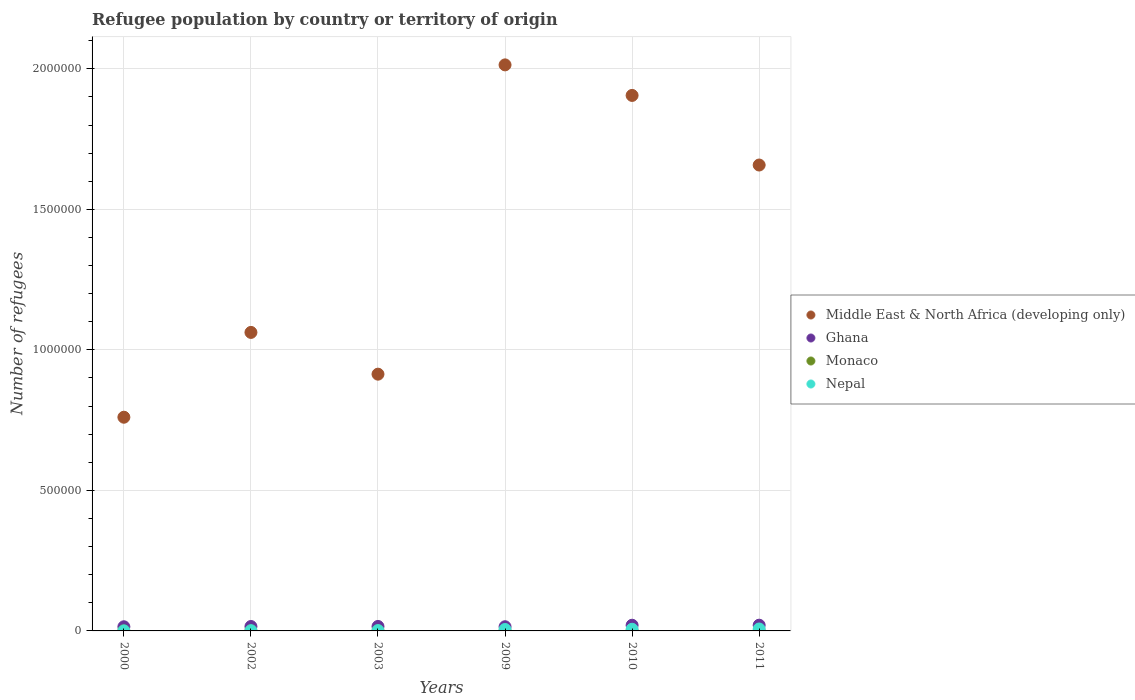How many different coloured dotlines are there?
Offer a very short reply. 4. What is the number of refugees in Nepal in 2003?
Your response must be concise. 1231. Across all years, what is the maximum number of refugees in Middle East & North Africa (developing only)?
Provide a succinct answer. 2.01e+06. Across all years, what is the minimum number of refugees in Nepal?
Your answer should be very brief. 235. What is the total number of refugees in Monaco in the graph?
Make the answer very short. 10. What is the difference between the number of refugees in Ghana in 2000 and that in 2002?
Your answer should be very brief. -911. What is the difference between the number of refugees in Ghana in 2011 and the number of refugees in Middle East & North Africa (developing only) in 2010?
Your answer should be compact. -1.88e+06. What is the average number of refugees in Monaco per year?
Your answer should be very brief. 1.67. In the year 2009, what is the difference between the number of refugees in Nepal and number of refugees in Monaco?
Offer a very short reply. 5107. In how many years, is the number of refugees in Middle East & North Africa (developing only) greater than 1700000?
Provide a short and direct response. 2. What is the ratio of the number of refugees in Middle East & North Africa (developing only) in 2002 to that in 2010?
Keep it short and to the point. 0.56. Is the number of refugees in Ghana in 2000 less than that in 2009?
Your answer should be compact. Yes. Is the difference between the number of refugees in Nepal in 2003 and 2011 greater than the difference between the number of refugees in Monaco in 2003 and 2011?
Make the answer very short. No. What is the difference between the highest and the second highest number of refugees in Middle East & North Africa (developing only)?
Offer a very short reply. 1.09e+05. What is the difference between the highest and the lowest number of refugees in Monaco?
Give a very brief answer. 3. Is the sum of the number of refugees in Nepal in 2002 and 2003 greater than the maximum number of refugees in Monaco across all years?
Make the answer very short. Yes. Is it the case that in every year, the sum of the number of refugees in Monaco and number of refugees in Middle East & North Africa (developing only)  is greater than the sum of number of refugees in Ghana and number of refugees in Nepal?
Give a very brief answer. Yes. How many years are there in the graph?
Provide a succinct answer. 6. Does the graph contain grids?
Give a very brief answer. Yes. What is the title of the graph?
Your answer should be compact. Refugee population by country or territory of origin. Does "Low income" appear as one of the legend labels in the graph?
Offer a very short reply. No. What is the label or title of the X-axis?
Offer a very short reply. Years. What is the label or title of the Y-axis?
Provide a short and direct response. Number of refugees. What is the Number of refugees in Middle East & North Africa (developing only) in 2000?
Provide a short and direct response. 7.60e+05. What is the Number of refugees of Ghana in 2000?
Offer a very short reply. 1.48e+04. What is the Number of refugees in Monaco in 2000?
Provide a short and direct response. 1. What is the Number of refugees of Nepal in 2000?
Your response must be concise. 235. What is the Number of refugees in Middle East & North Africa (developing only) in 2002?
Provide a succinct answer. 1.06e+06. What is the Number of refugees in Ghana in 2002?
Offer a terse response. 1.57e+04. What is the Number of refugees in Nepal in 2002?
Your answer should be very brief. 902. What is the Number of refugees of Middle East & North Africa (developing only) in 2003?
Offer a terse response. 9.14e+05. What is the Number of refugees in Ghana in 2003?
Ensure brevity in your answer.  1.59e+04. What is the Number of refugees of Nepal in 2003?
Offer a very short reply. 1231. What is the Number of refugees in Middle East & North Africa (developing only) in 2009?
Offer a terse response. 2.01e+06. What is the Number of refugees of Ghana in 2009?
Keep it short and to the point. 1.49e+04. What is the Number of refugees in Monaco in 2009?
Offer a very short reply. 1. What is the Number of refugees in Nepal in 2009?
Offer a terse response. 5108. What is the Number of refugees of Middle East & North Africa (developing only) in 2010?
Your response must be concise. 1.91e+06. What is the Number of refugees of Ghana in 2010?
Your answer should be compact. 2.02e+04. What is the Number of refugees of Monaco in 2010?
Your answer should be compact. 2. What is the Number of refugees in Nepal in 2010?
Offer a very short reply. 5889. What is the Number of refugees of Middle East & North Africa (developing only) in 2011?
Offer a very short reply. 1.66e+06. What is the Number of refugees of Ghana in 2011?
Your answer should be compact. 2.04e+04. What is the Number of refugees in Monaco in 2011?
Offer a terse response. 4. What is the Number of refugees of Nepal in 2011?
Offer a very short reply. 6854. Across all years, what is the maximum Number of refugees in Middle East & North Africa (developing only)?
Keep it short and to the point. 2.01e+06. Across all years, what is the maximum Number of refugees of Ghana?
Offer a terse response. 2.04e+04. Across all years, what is the maximum Number of refugees in Monaco?
Ensure brevity in your answer.  4. Across all years, what is the maximum Number of refugees of Nepal?
Provide a short and direct response. 6854. Across all years, what is the minimum Number of refugees of Middle East & North Africa (developing only)?
Your answer should be compact. 7.60e+05. Across all years, what is the minimum Number of refugees of Ghana?
Keep it short and to the point. 1.48e+04. Across all years, what is the minimum Number of refugees of Monaco?
Your answer should be compact. 1. Across all years, what is the minimum Number of refugees of Nepal?
Ensure brevity in your answer.  235. What is the total Number of refugees of Middle East & North Africa (developing only) in the graph?
Your answer should be compact. 8.31e+06. What is the total Number of refugees in Ghana in the graph?
Provide a short and direct response. 1.02e+05. What is the total Number of refugees of Monaco in the graph?
Provide a short and direct response. 10. What is the total Number of refugees in Nepal in the graph?
Your answer should be compact. 2.02e+04. What is the difference between the Number of refugees of Middle East & North Africa (developing only) in 2000 and that in 2002?
Offer a terse response. -3.02e+05. What is the difference between the Number of refugees in Ghana in 2000 and that in 2002?
Your response must be concise. -911. What is the difference between the Number of refugees of Nepal in 2000 and that in 2002?
Your answer should be very brief. -667. What is the difference between the Number of refugees in Middle East & North Africa (developing only) in 2000 and that in 2003?
Provide a short and direct response. -1.53e+05. What is the difference between the Number of refugees of Ghana in 2000 and that in 2003?
Make the answer very short. -1104. What is the difference between the Number of refugees in Nepal in 2000 and that in 2003?
Keep it short and to the point. -996. What is the difference between the Number of refugees in Middle East & North Africa (developing only) in 2000 and that in 2009?
Keep it short and to the point. -1.25e+06. What is the difference between the Number of refugees in Ghana in 2000 and that in 2009?
Offer a very short reply. -118. What is the difference between the Number of refugees of Nepal in 2000 and that in 2009?
Your response must be concise. -4873. What is the difference between the Number of refugees in Middle East & North Africa (developing only) in 2000 and that in 2010?
Your response must be concise. -1.14e+06. What is the difference between the Number of refugees of Ghana in 2000 and that in 2010?
Your response must be concise. -5428. What is the difference between the Number of refugees in Nepal in 2000 and that in 2010?
Make the answer very short. -5654. What is the difference between the Number of refugees of Middle East & North Africa (developing only) in 2000 and that in 2011?
Provide a succinct answer. -8.97e+05. What is the difference between the Number of refugees in Ghana in 2000 and that in 2011?
Keep it short and to the point. -5586. What is the difference between the Number of refugees in Nepal in 2000 and that in 2011?
Your response must be concise. -6619. What is the difference between the Number of refugees of Middle East & North Africa (developing only) in 2002 and that in 2003?
Your response must be concise. 1.49e+05. What is the difference between the Number of refugees in Ghana in 2002 and that in 2003?
Offer a terse response. -193. What is the difference between the Number of refugees in Nepal in 2002 and that in 2003?
Keep it short and to the point. -329. What is the difference between the Number of refugees of Middle East & North Africa (developing only) in 2002 and that in 2009?
Your answer should be compact. -9.52e+05. What is the difference between the Number of refugees in Ghana in 2002 and that in 2009?
Make the answer very short. 793. What is the difference between the Number of refugees in Nepal in 2002 and that in 2009?
Your response must be concise. -4206. What is the difference between the Number of refugees of Middle East & North Africa (developing only) in 2002 and that in 2010?
Provide a short and direct response. -8.43e+05. What is the difference between the Number of refugees in Ghana in 2002 and that in 2010?
Offer a very short reply. -4517. What is the difference between the Number of refugees of Nepal in 2002 and that in 2010?
Provide a succinct answer. -4987. What is the difference between the Number of refugees in Middle East & North Africa (developing only) in 2002 and that in 2011?
Ensure brevity in your answer.  -5.96e+05. What is the difference between the Number of refugees of Ghana in 2002 and that in 2011?
Provide a succinct answer. -4675. What is the difference between the Number of refugees of Nepal in 2002 and that in 2011?
Your answer should be very brief. -5952. What is the difference between the Number of refugees in Middle East & North Africa (developing only) in 2003 and that in 2009?
Keep it short and to the point. -1.10e+06. What is the difference between the Number of refugees in Ghana in 2003 and that in 2009?
Offer a very short reply. 986. What is the difference between the Number of refugees in Nepal in 2003 and that in 2009?
Your answer should be compact. -3877. What is the difference between the Number of refugees of Middle East & North Africa (developing only) in 2003 and that in 2010?
Offer a terse response. -9.92e+05. What is the difference between the Number of refugees in Ghana in 2003 and that in 2010?
Make the answer very short. -4324. What is the difference between the Number of refugees in Nepal in 2003 and that in 2010?
Provide a short and direct response. -4658. What is the difference between the Number of refugees in Middle East & North Africa (developing only) in 2003 and that in 2011?
Your answer should be very brief. -7.44e+05. What is the difference between the Number of refugees of Ghana in 2003 and that in 2011?
Offer a very short reply. -4482. What is the difference between the Number of refugees in Monaco in 2003 and that in 2011?
Make the answer very short. -3. What is the difference between the Number of refugees of Nepal in 2003 and that in 2011?
Your response must be concise. -5623. What is the difference between the Number of refugees of Middle East & North Africa (developing only) in 2009 and that in 2010?
Keep it short and to the point. 1.09e+05. What is the difference between the Number of refugees of Ghana in 2009 and that in 2010?
Your response must be concise. -5310. What is the difference between the Number of refugees of Monaco in 2009 and that in 2010?
Your answer should be compact. -1. What is the difference between the Number of refugees in Nepal in 2009 and that in 2010?
Offer a terse response. -781. What is the difference between the Number of refugees of Middle East & North Africa (developing only) in 2009 and that in 2011?
Your answer should be compact. 3.56e+05. What is the difference between the Number of refugees in Ghana in 2009 and that in 2011?
Offer a terse response. -5468. What is the difference between the Number of refugees in Nepal in 2009 and that in 2011?
Offer a terse response. -1746. What is the difference between the Number of refugees of Middle East & North Africa (developing only) in 2010 and that in 2011?
Give a very brief answer. 2.48e+05. What is the difference between the Number of refugees in Ghana in 2010 and that in 2011?
Ensure brevity in your answer.  -158. What is the difference between the Number of refugees in Nepal in 2010 and that in 2011?
Make the answer very short. -965. What is the difference between the Number of refugees of Middle East & North Africa (developing only) in 2000 and the Number of refugees of Ghana in 2002?
Offer a terse response. 7.45e+05. What is the difference between the Number of refugees in Middle East & North Africa (developing only) in 2000 and the Number of refugees in Monaco in 2002?
Offer a terse response. 7.60e+05. What is the difference between the Number of refugees in Middle East & North Africa (developing only) in 2000 and the Number of refugees in Nepal in 2002?
Keep it short and to the point. 7.59e+05. What is the difference between the Number of refugees in Ghana in 2000 and the Number of refugees in Monaco in 2002?
Give a very brief answer. 1.48e+04. What is the difference between the Number of refugees in Ghana in 2000 and the Number of refugees in Nepal in 2002?
Provide a short and direct response. 1.39e+04. What is the difference between the Number of refugees of Monaco in 2000 and the Number of refugees of Nepal in 2002?
Your answer should be very brief. -901. What is the difference between the Number of refugees in Middle East & North Africa (developing only) in 2000 and the Number of refugees in Ghana in 2003?
Make the answer very short. 7.44e+05. What is the difference between the Number of refugees in Middle East & North Africa (developing only) in 2000 and the Number of refugees in Monaco in 2003?
Your response must be concise. 7.60e+05. What is the difference between the Number of refugees in Middle East & North Africa (developing only) in 2000 and the Number of refugees in Nepal in 2003?
Ensure brevity in your answer.  7.59e+05. What is the difference between the Number of refugees of Ghana in 2000 and the Number of refugees of Monaco in 2003?
Ensure brevity in your answer.  1.48e+04. What is the difference between the Number of refugees in Ghana in 2000 and the Number of refugees in Nepal in 2003?
Provide a short and direct response. 1.35e+04. What is the difference between the Number of refugees of Monaco in 2000 and the Number of refugees of Nepal in 2003?
Your response must be concise. -1230. What is the difference between the Number of refugees in Middle East & North Africa (developing only) in 2000 and the Number of refugees in Ghana in 2009?
Ensure brevity in your answer.  7.45e+05. What is the difference between the Number of refugees of Middle East & North Africa (developing only) in 2000 and the Number of refugees of Monaco in 2009?
Provide a short and direct response. 7.60e+05. What is the difference between the Number of refugees of Middle East & North Africa (developing only) in 2000 and the Number of refugees of Nepal in 2009?
Keep it short and to the point. 7.55e+05. What is the difference between the Number of refugees in Ghana in 2000 and the Number of refugees in Monaco in 2009?
Your answer should be compact. 1.48e+04. What is the difference between the Number of refugees in Ghana in 2000 and the Number of refugees in Nepal in 2009?
Your response must be concise. 9667. What is the difference between the Number of refugees of Monaco in 2000 and the Number of refugees of Nepal in 2009?
Provide a succinct answer. -5107. What is the difference between the Number of refugees of Middle East & North Africa (developing only) in 2000 and the Number of refugees of Ghana in 2010?
Ensure brevity in your answer.  7.40e+05. What is the difference between the Number of refugees in Middle East & North Africa (developing only) in 2000 and the Number of refugees in Monaco in 2010?
Offer a very short reply. 7.60e+05. What is the difference between the Number of refugees in Middle East & North Africa (developing only) in 2000 and the Number of refugees in Nepal in 2010?
Keep it short and to the point. 7.54e+05. What is the difference between the Number of refugees in Ghana in 2000 and the Number of refugees in Monaco in 2010?
Keep it short and to the point. 1.48e+04. What is the difference between the Number of refugees of Ghana in 2000 and the Number of refugees of Nepal in 2010?
Provide a succinct answer. 8886. What is the difference between the Number of refugees in Monaco in 2000 and the Number of refugees in Nepal in 2010?
Your answer should be compact. -5888. What is the difference between the Number of refugees in Middle East & North Africa (developing only) in 2000 and the Number of refugees in Ghana in 2011?
Ensure brevity in your answer.  7.40e+05. What is the difference between the Number of refugees of Middle East & North Africa (developing only) in 2000 and the Number of refugees of Monaco in 2011?
Make the answer very short. 7.60e+05. What is the difference between the Number of refugees in Middle East & North Africa (developing only) in 2000 and the Number of refugees in Nepal in 2011?
Your answer should be compact. 7.53e+05. What is the difference between the Number of refugees of Ghana in 2000 and the Number of refugees of Monaco in 2011?
Your answer should be compact. 1.48e+04. What is the difference between the Number of refugees in Ghana in 2000 and the Number of refugees in Nepal in 2011?
Provide a short and direct response. 7921. What is the difference between the Number of refugees in Monaco in 2000 and the Number of refugees in Nepal in 2011?
Your answer should be very brief. -6853. What is the difference between the Number of refugees in Middle East & North Africa (developing only) in 2002 and the Number of refugees in Ghana in 2003?
Ensure brevity in your answer.  1.05e+06. What is the difference between the Number of refugees in Middle East & North Africa (developing only) in 2002 and the Number of refugees in Monaco in 2003?
Provide a short and direct response. 1.06e+06. What is the difference between the Number of refugees in Middle East & North Africa (developing only) in 2002 and the Number of refugees in Nepal in 2003?
Make the answer very short. 1.06e+06. What is the difference between the Number of refugees in Ghana in 2002 and the Number of refugees in Monaco in 2003?
Keep it short and to the point. 1.57e+04. What is the difference between the Number of refugees of Ghana in 2002 and the Number of refugees of Nepal in 2003?
Provide a short and direct response. 1.45e+04. What is the difference between the Number of refugees in Monaco in 2002 and the Number of refugees in Nepal in 2003?
Provide a short and direct response. -1230. What is the difference between the Number of refugees of Middle East & North Africa (developing only) in 2002 and the Number of refugees of Ghana in 2009?
Make the answer very short. 1.05e+06. What is the difference between the Number of refugees of Middle East & North Africa (developing only) in 2002 and the Number of refugees of Monaco in 2009?
Make the answer very short. 1.06e+06. What is the difference between the Number of refugees of Middle East & North Africa (developing only) in 2002 and the Number of refugees of Nepal in 2009?
Provide a succinct answer. 1.06e+06. What is the difference between the Number of refugees in Ghana in 2002 and the Number of refugees in Monaco in 2009?
Make the answer very short. 1.57e+04. What is the difference between the Number of refugees of Ghana in 2002 and the Number of refugees of Nepal in 2009?
Your response must be concise. 1.06e+04. What is the difference between the Number of refugees in Monaco in 2002 and the Number of refugees in Nepal in 2009?
Offer a terse response. -5107. What is the difference between the Number of refugees in Middle East & North Africa (developing only) in 2002 and the Number of refugees in Ghana in 2010?
Make the answer very short. 1.04e+06. What is the difference between the Number of refugees in Middle East & North Africa (developing only) in 2002 and the Number of refugees in Monaco in 2010?
Ensure brevity in your answer.  1.06e+06. What is the difference between the Number of refugees in Middle East & North Africa (developing only) in 2002 and the Number of refugees in Nepal in 2010?
Your answer should be very brief. 1.06e+06. What is the difference between the Number of refugees of Ghana in 2002 and the Number of refugees of Monaco in 2010?
Ensure brevity in your answer.  1.57e+04. What is the difference between the Number of refugees in Ghana in 2002 and the Number of refugees in Nepal in 2010?
Ensure brevity in your answer.  9797. What is the difference between the Number of refugees in Monaco in 2002 and the Number of refugees in Nepal in 2010?
Keep it short and to the point. -5888. What is the difference between the Number of refugees of Middle East & North Africa (developing only) in 2002 and the Number of refugees of Ghana in 2011?
Your answer should be compact. 1.04e+06. What is the difference between the Number of refugees in Middle East & North Africa (developing only) in 2002 and the Number of refugees in Monaco in 2011?
Give a very brief answer. 1.06e+06. What is the difference between the Number of refugees in Middle East & North Africa (developing only) in 2002 and the Number of refugees in Nepal in 2011?
Your answer should be very brief. 1.06e+06. What is the difference between the Number of refugees in Ghana in 2002 and the Number of refugees in Monaco in 2011?
Ensure brevity in your answer.  1.57e+04. What is the difference between the Number of refugees in Ghana in 2002 and the Number of refugees in Nepal in 2011?
Your answer should be compact. 8832. What is the difference between the Number of refugees of Monaco in 2002 and the Number of refugees of Nepal in 2011?
Offer a very short reply. -6853. What is the difference between the Number of refugees in Middle East & North Africa (developing only) in 2003 and the Number of refugees in Ghana in 2009?
Offer a terse response. 8.99e+05. What is the difference between the Number of refugees in Middle East & North Africa (developing only) in 2003 and the Number of refugees in Monaco in 2009?
Make the answer very short. 9.14e+05. What is the difference between the Number of refugees in Middle East & North Africa (developing only) in 2003 and the Number of refugees in Nepal in 2009?
Provide a succinct answer. 9.08e+05. What is the difference between the Number of refugees in Ghana in 2003 and the Number of refugees in Monaco in 2009?
Your answer should be compact. 1.59e+04. What is the difference between the Number of refugees in Ghana in 2003 and the Number of refugees in Nepal in 2009?
Your answer should be very brief. 1.08e+04. What is the difference between the Number of refugees of Monaco in 2003 and the Number of refugees of Nepal in 2009?
Your response must be concise. -5107. What is the difference between the Number of refugees in Middle East & North Africa (developing only) in 2003 and the Number of refugees in Ghana in 2010?
Offer a terse response. 8.93e+05. What is the difference between the Number of refugees of Middle East & North Africa (developing only) in 2003 and the Number of refugees of Monaco in 2010?
Your answer should be very brief. 9.14e+05. What is the difference between the Number of refugees of Middle East & North Africa (developing only) in 2003 and the Number of refugees of Nepal in 2010?
Give a very brief answer. 9.08e+05. What is the difference between the Number of refugees in Ghana in 2003 and the Number of refugees in Monaco in 2010?
Give a very brief answer. 1.59e+04. What is the difference between the Number of refugees in Ghana in 2003 and the Number of refugees in Nepal in 2010?
Make the answer very short. 9990. What is the difference between the Number of refugees in Monaco in 2003 and the Number of refugees in Nepal in 2010?
Make the answer very short. -5888. What is the difference between the Number of refugees in Middle East & North Africa (developing only) in 2003 and the Number of refugees in Ghana in 2011?
Give a very brief answer. 8.93e+05. What is the difference between the Number of refugees of Middle East & North Africa (developing only) in 2003 and the Number of refugees of Monaco in 2011?
Ensure brevity in your answer.  9.14e+05. What is the difference between the Number of refugees of Middle East & North Africa (developing only) in 2003 and the Number of refugees of Nepal in 2011?
Your answer should be very brief. 9.07e+05. What is the difference between the Number of refugees of Ghana in 2003 and the Number of refugees of Monaco in 2011?
Offer a terse response. 1.59e+04. What is the difference between the Number of refugees in Ghana in 2003 and the Number of refugees in Nepal in 2011?
Your answer should be very brief. 9025. What is the difference between the Number of refugees in Monaco in 2003 and the Number of refugees in Nepal in 2011?
Make the answer very short. -6853. What is the difference between the Number of refugees of Middle East & North Africa (developing only) in 2009 and the Number of refugees of Ghana in 2010?
Your answer should be very brief. 1.99e+06. What is the difference between the Number of refugees in Middle East & North Africa (developing only) in 2009 and the Number of refugees in Monaco in 2010?
Keep it short and to the point. 2.01e+06. What is the difference between the Number of refugees in Middle East & North Africa (developing only) in 2009 and the Number of refugees in Nepal in 2010?
Provide a succinct answer. 2.01e+06. What is the difference between the Number of refugees in Ghana in 2009 and the Number of refugees in Monaco in 2010?
Ensure brevity in your answer.  1.49e+04. What is the difference between the Number of refugees of Ghana in 2009 and the Number of refugees of Nepal in 2010?
Your answer should be compact. 9004. What is the difference between the Number of refugees of Monaco in 2009 and the Number of refugees of Nepal in 2010?
Your response must be concise. -5888. What is the difference between the Number of refugees in Middle East & North Africa (developing only) in 2009 and the Number of refugees in Ghana in 2011?
Provide a succinct answer. 1.99e+06. What is the difference between the Number of refugees of Middle East & North Africa (developing only) in 2009 and the Number of refugees of Monaco in 2011?
Keep it short and to the point. 2.01e+06. What is the difference between the Number of refugees in Middle East & North Africa (developing only) in 2009 and the Number of refugees in Nepal in 2011?
Provide a succinct answer. 2.01e+06. What is the difference between the Number of refugees of Ghana in 2009 and the Number of refugees of Monaco in 2011?
Provide a short and direct response. 1.49e+04. What is the difference between the Number of refugees in Ghana in 2009 and the Number of refugees in Nepal in 2011?
Keep it short and to the point. 8039. What is the difference between the Number of refugees of Monaco in 2009 and the Number of refugees of Nepal in 2011?
Your response must be concise. -6853. What is the difference between the Number of refugees in Middle East & North Africa (developing only) in 2010 and the Number of refugees in Ghana in 2011?
Ensure brevity in your answer.  1.88e+06. What is the difference between the Number of refugees of Middle East & North Africa (developing only) in 2010 and the Number of refugees of Monaco in 2011?
Offer a very short reply. 1.91e+06. What is the difference between the Number of refugees of Middle East & North Africa (developing only) in 2010 and the Number of refugees of Nepal in 2011?
Make the answer very short. 1.90e+06. What is the difference between the Number of refugees of Ghana in 2010 and the Number of refugees of Monaco in 2011?
Keep it short and to the point. 2.02e+04. What is the difference between the Number of refugees of Ghana in 2010 and the Number of refugees of Nepal in 2011?
Make the answer very short. 1.33e+04. What is the difference between the Number of refugees in Monaco in 2010 and the Number of refugees in Nepal in 2011?
Your answer should be very brief. -6852. What is the average Number of refugees in Middle East & North Africa (developing only) per year?
Provide a short and direct response. 1.39e+06. What is the average Number of refugees of Ghana per year?
Make the answer very short. 1.70e+04. What is the average Number of refugees in Nepal per year?
Offer a terse response. 3369.83. In the year 2000, what is the difference between the Number of refugees in Middle East & North Africa (developing only) and Number of refugees in Ghana?
Give a very brief answer. 7.46e+05. In the year 2000, what is the difference between the Number of refugees in Middle East & North Africa (developing only) and Number of refugees in Monaco?
Make the answer very short. 7.60e+05. In the year 2000, what is the difference between the Number of refugees in Middle East & North Africa (developing only) and Number of refugees in Nepal?
Provide a short and direct response. 7.60e+05. In the year 2000, what is the difference between the Number of refugees of Ghana and Number of refugees of Monaco?
Keep it short and to the point. 1.48e+04. In the year 2000, what is the difference between the Number of refugees of Ghana and Number of refugees of Nepal?
Your answer should be compact. 1.45e+04. In the year 2000, what is the difference between the Number of refugees of Monaco and Number of refugees of Nepal?
Keep it short and to the point. -234. In the year 2002, what is the difference between the Number of refugees in Middle East & North Africa (developing only) and Number of refugees in Ghana?
Offer a very short reply. 1.05e+06. In the year 2002, what is the difference between the Number of refugees of Middle East & North Africa (developing only) and Number of refugees of Monaco?
Provide a short and direct response. 1.06e+06. In the year 2002, what is the difference between the Number of refugees of Middle East & North Africa (developing only) and Number of refugees of Nepal?
Your response must be concise. 1.06e+06. In the year 2002, what is the difference between the Number of refugees in Ghana and Number of refugees in Monaco?
Provide a succinct answer. 1.57e+04. In the year 2002, what is the difference between the Number of refugees of Ghana and Number of refugees of Nepal?
Offer a terse response. 1.48e+04. In the year 2002, what is the difference between the Number of refugees of Monaco and Number of refugees of Nepal?
Ensure brevity in your answer.  -901. In the year 2003, what is the difference between the Number of refugees in Middle East & North Africa (developing only) and Number of refugees in Ghana?
Your answer should be very brief. 8.98e+05. In the year 2003, what is the difference between the Number of refugees of Middle East & North Africa (developing only) and Number of refugees of Monaco?
Make the answer very short. 9.14e+05. In the year 2003, what is the difference between the Number of refugees of Middle East & North Africa (developing only) and Number of refugees of Nepal?
Your response must be concise. 9.12e+05. In the year 2003, what is the difference between the Number of refugees of Ghana and Number of refugees of Monaco?
Ensure brevity in your answer.  1.59e+04. In the year 2003, what is the difference between the Number of refugees of Ghana and Number of refugees of Nepal?
Make the answer very short. 1.46e+04. In the year 2003, what is the difference between the Number of refugees in Monaco and Number of refugees in Nepal?
Offer a terse response. -1230. In the year 2009, what is the difference between the Number of refugees of Middle East & North Africa (developing only) and Number of refugees of Ghana?
Your response must be concise. 2.00e+06. In the year 2009, what is the difference between the Number of refugees in Middle East & North Africa (developing only) and Number of refugees in Monaco?
Offer a very short reply. 2.01e+06. In the year 2009, what is the difference between the Number of refugees of Middle East & North Africa (developing only) and Number of refugees of Nepal?
Give a very brief answer. 2.01e+06. In the year 2009, what is the difference between the Number of refugees of Ghana and Number of refugees of Monaco?
Your response must be concise. 1.49e+04. In the year 2009, what is the difference between the Number of refugees in Ghana and Number of refugees in Nepal?
Your response must be concise. 9785. In the year 2009, what is the difference between the Number of refugees of Monaco and Number of refugees of Nepal?
Give a very brief answer. -5107. In the year 2010, what is the difference between the Number of refugees of Middle East & North Africa (developing only) and Number of refugees of Ghana?
Offer a terse response. 1.89e+06. In the year 2010, what is the difference between the Number of refugees in Middle East & North Africa (developing only) and Number of refugees in Monaco?
Make the answer very short. 1.91e+06. In the year 2010, what is the difference between the Number of refugees of Middle East & North Africa (developing only) and Number of refugees of Nepal?
Provide a short and direct response. 1.90e+06. In the year 2010, what is the difference between the Number of refugees in Ghana and Number of refugees in Monaco?
Provide a succinct answer. 2.02e+04. In the year 2010, what is the difference between the Number of refugees of Ghana and Number of refugees of Nepal?
Make the answer very short. 1.43e+04. In the year 2010, what is the difference between the Number of refugees of Monaco and Number of refugees of Nepal?
Offer a terse response. -5887. In the year 2011, what is the difference between the Number of refugees in Middle East & North Africa (developing only) and Number of refugees in Ghana?
Offer a very short reply. 1.64e+06. In the year 2011, what is the difference between the Number of refugees of Middle East & North Africa (developing only) and Number of refugees of Monaco?
Offer a very short reply. 1.66e+06. In the year 2011, what is the difference between the Number of refugees of Middle East & North Africa (developing only) and Number of refugees of Nepal?
Ensure brevity in your answer.  1.65e+06. In the year 2011, what is the difference between the Number of refugees of Ghana and Number of refugees of Monaco?
Ensure brevity in your answer.  2.04e+04. In the year 2011, what is the difference between the Number of refugees of Ghana and Number of refugees of Nepal?
Offer a terse response. 1.35e+04. In the year 2011, what is the difference between the Number of refugees of Monaco and Number of refugees of Nepal?
Offer a very short reply. -6850. What is the ratio of the Number of refugees of Middle East & North Africa (developing only) in 2000 to that in 2002?
Make the answer very short. 0.72. What is the ratio of the Number of refugees in Ghana in 2000 to that in 2002?
Your answer should be compact. 0.94. What is the ratio of the Number of refugees of Monaco in 2000 to that in 2002?
Keep it short and to the point. 1. What is the ratio of the Number of refugees in Nepal in 2000 to that in 2002?
Make the answer very short. 0.26. What is the ratio of the Number of refugees in Middle East & North Africa (developing only) in 2000 to that in 2003?
Give a very brief answer. 0.83. What is the ratio of the Number of refugees of Ghana in 2000 to that in 2003?
Provide a succinct answer. 0.93. What is the ratio of the Number of refugees of Nepal in 2000 to that in 2003?
Provide a short and direct response. 0.19. What is the ratio of the Number of refugees in Middle East & North Africa (developing only) in 2000 to that in 2009?
Provide a short and direct response. 0.38. What is the ratio of the Number of refugees in Ghana in 2000 to that in 2009?
Give a very brief answer. 0.99. What is the ratio of the Number of refugees of Nepal in 2000 to that in 2009?
Your answer should be very brief. 0.05. What is the ratio of the Number of refugees in Middle East & North Africa (developing only) in 2000 to that in 2010?
Provide a short and direct response. 0.4. What is the ratio of the Number of refugees in Ghana in 2000 to that in 2010?
Offer a very short reply. 0.73. What is the ratio of the Number of refugees of Monaco in 2000 to that in 2010?
Offer a terse response. 0.5. What is the ratio of the Number of refugees of Nepal in 2000 to that in 2010?
Provide a succinct answer. 0.04. What is the ratio of the Number of refugees of Middle East & North Africa (developing only) in 2000 to that in 2011?
Your response must be concise. 0.46. What is the ratio of the Number of refugees of Ghana in 2000 to that in 2011?
Provide a succinct answer. 0.73. What is the ratio of the Number of refugees in Nepal in 2000 to that in 2011?
Ensure brevity in your answer.  0.03. What is the ratio of the Number of refugees of Middle East & North Africa (developing only) in 2002 to that in 2003?
Keep it short and to the point. 1.16. What is the ratio of the Number of refugees in Ghana in 2002 to that in 2003?
Keep it short and to the point. 0.99. What is the ratio of the Number of refugees of Monaco in 2002 to that in 2003?
Your response must be concise. 1. What is the ratio of the Number of refugees in Nepal in 2002 to that in 2003?
Your response must be concise. 0.73. What is the ratio of the Number of refugees of Middle East & North Africa (developing only) in 2002 to that in 2009?
Make the answer very short. 0.53. What is the ratio of the Number of refugees of Ghana in 2002 to that in 2009?
Your response must be concise. 1.05. What is the ratio of the Number of refugees of Nepal in 2002 to that in 2009?
Keep it short and to the point. 0.18. What is the ratio of the Number of refugees in Middle East & North Africa (developing only) in 2002 to that in 2010?
Give a very brief answer. 0.56. What is the ratio of the Number of refugees in Ghana in 2002 to that in 2010?
Ensure brevity in your answer.  0.78. What is the ratio of the Number of refugees of Nepal in 2002 to that in 2010?
Ensure brevity in your answer.  0.15. What is the ratio of the Number of refugees of Middle East & North Africa (developing only) in 2002 to that in 2011?
Give a very brief answer. 0.64. What is the ratio of the Number of refugees of Ghana in 2002 to that in 2011?
Your response must be concise. 0.77. What is the ratio of the Number of refugees of Monaco in 2002 to that in 2011?
Ensure brevity in your answer.  0.25. What is the ratio of the Number of refugees of Nepal in 2002 to that in 2011?
Offer a very short reply. 0.13. What is the ratio of the Number of refugees in Middle East & North Africa (developing only) in 2003 to that in 2009?
Provide a short and direct response. 0.45. What is the ratio of the Number of refugees of Ghana in 2003 to that in 2009?
Your response must be concise. 1.07. What is the ratio of the Number of refugees in Nepal in 2003 to that in 2009?
Ensure brevity in your answer.  0.24. What is the ratio of the Number of refugees in Middle East & North Africa (developing only) in 2003 to that in 2010?
Your answer should be compact. 0.48. What is the ratio of the Number of refugees of Ghana in 2003 to that in 2010?
Your response must be concise. 0.79. What is the ratio of the Number of refugees of Monaco in 2003 to that in 2010?
Provide a short and direct response. 0.5. What is the ratio of the Number of refugees of Nepal in 2003 to that in 2010?
Ensure brevity in your answer.  0.21. What is the ratio of the Number of refugees in Middle East & North Africa (developing only) in 2003 to that in 2011?
Keep it short and to the point. 0.55. What is the ratio of the Number of refugees of Ghana in 2003 to that in 2011?
Provide a short and direct response. 0.78. What is the ratio of the Number of refugees of Monaco in 2003 to that in 2011?
Give a very brief answer. 0.25. What is the ratio of the Number of refugees of Nepal in 2003 to that in 2011?
Provide a short and direct response. 0.18. What is the ratio of the Number of refugees in Middle East & North Africa (developing only) in 2009 to that in 2010?
Give a very brief answer. 1.06. What is the ratio of the Number of refugees of Ghana in 2009 to that in 2010?
Offer a very short reply. 0.74. What is the ratio of the Number of refugees in Monaco in 2009 to that in 2010?
Make the answer very short. 0.5. What is the ratio of the Number of refugees in Nepal in 2009 to that in 2010?
Ensure brevity in your answer.  0.87. What is the ratio of the Number of refugees of Middle East & North Africa (developing only) in 2009 to that in 2011?
Your answer should be very brief. 1.22. What is the ratio of the Number of refugees in Ghana in 2009 to that in 2011?
Your response must be concise. 0.73. What is the ratio of the Number of refugees of Monaco in 2009 to that in 2011?
Your answer should be very brief. 0.25. What is the ratio of the Number of refugees in Nepal in 2009 to that in 2011?
Offer a very short reply. 0.75. What is the ratio of the Number of refugees in Middle East & North Africa (developing only) in 2010 to that in 2011?
Give a very brief answer. 1.15. What is the ratio of the Number of refugees of Ghana in 2010 to that in 2011?
Ensure brevity in your answer.  0.99. What is the ratio of the Number of refugees of Monaco in 2010 to that in 2011?
Your response must be concise. 0.5. What is the ratio of the Number of refugees of Nepal in 2010 to that in 2011?
Make the answer very short. 0.86. What is the difference between the highest and the second highest Number of refugees in Middle East & North Africa (developing only)?
Give a very brief answer. 1.09e+05. What is the difference between the highest and the second highest Number of refugees in Ghana?
Ensure brevity in your answer.  158. What is the difference between the highest and the second highest Number of refugees of Monaco?
Offer a very short reply. 2. What is the difference between the highest and the second highest Number of refugees of Nepal?
Offer a very short reply. 965. What is the difference between the highest and the lowest Number of refugees in Middle East & North Africa (developing only)?
Your answer should be compact. 1.25e+06. What is the difference between the highest and the lowest Number of refugees in Ghana?
Make the answer very short. 5586. What is the difference between the highest and the lowest Number of refugees in Monaco?
Ensure brevity in your answer.  3. What is the difference between the highest and the lowest Number of refugees in Nepal?
Make the answer very short. 6619. 